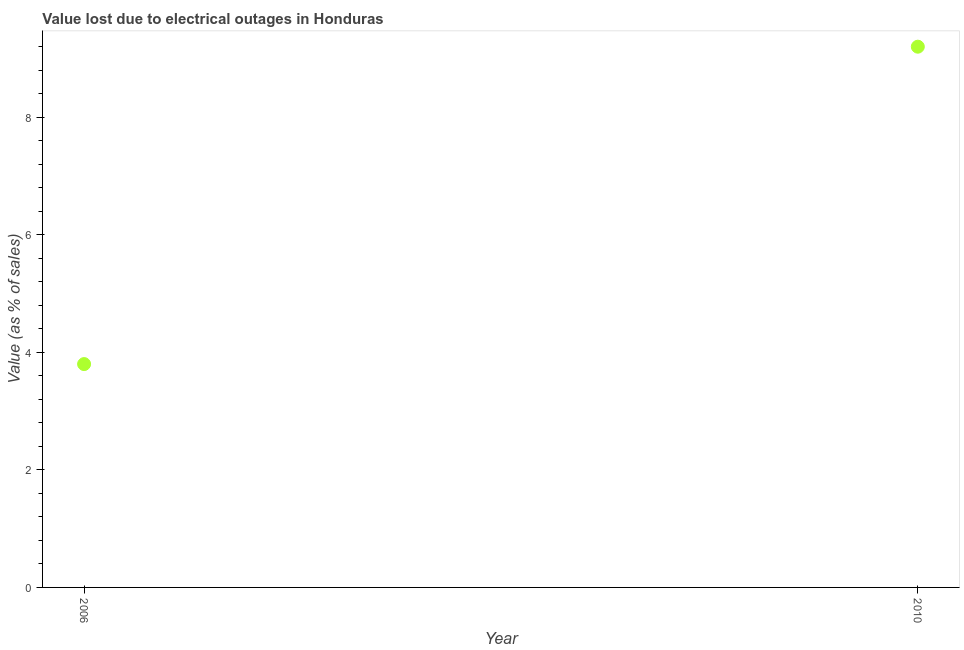What is the value lost due to electrical outages in 2010?
Provide a succinct answer. 9.2. In which year was the value lost due to electrical outages maximum?
Your answer should be very brief. 2010. What is the difference between the value lost due to electrical outages in 2006 and 2010?
Ensure brevity in your answer.  -5.4. What is the average value lost due to electrical outages per year?
Your response must be concise. 6.5. What is the ratio of the value lost due to electrical outages in 2006 to that in 2010?
Offer a terse response. 0.41. Is the value lost due to electrical outages in 2006 less than that in 2010?
Make the answer very short. Yes. Does the value lost due to electrical outages monotonically increase over the years?
Offer a terse response. Yes. How many dotlines are there?
Your response must be concise. 1. How many years are there in the graph?
Provide a succinct answer. 2. Are the values on the major ticks of Y-axis written in scientific E-notation?
Provide a succinct answer. No. Does the graph contain any zero values?
Offer a very short reply. No. What is the title of the graph?
Provide a succinct answer. Value lost due to electrical outages in Honduras. What is the label or title of the Y-axis?
Make the answer very short. Value (as % of sales). What is the Value (as % of sales) in 2010?
Ensure brevity in your answer.  9.2. What is the ratio of the Value (as % of sales) in 2006 to that in 2010?
Provide a short and direct response. 0.41. 